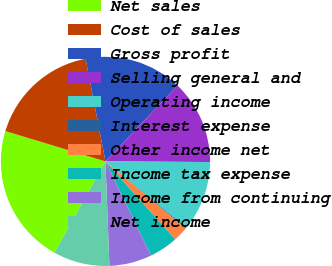<chart> <loc_0><loc_0><loc_500><loc_500><pie_chart><fcel>Net sales<fcel>Cost of sales<fcel>Gross profit<fcel>Selling general and<fcel>Operating income<fcel>Interest expense<fcel>Other income net<fcel>Income tax expense<fcel>Income from continuing<fcel>Net income<nl><fcel>21.56%<fcel>17.28%<fcel>15.14%<fcel>13.0%<fcel>10.86%<fcel>0.15%<fcel>2.29%<fcel>4.43%<fcel>6.57%<fcel>8.72%<nl></chart> 